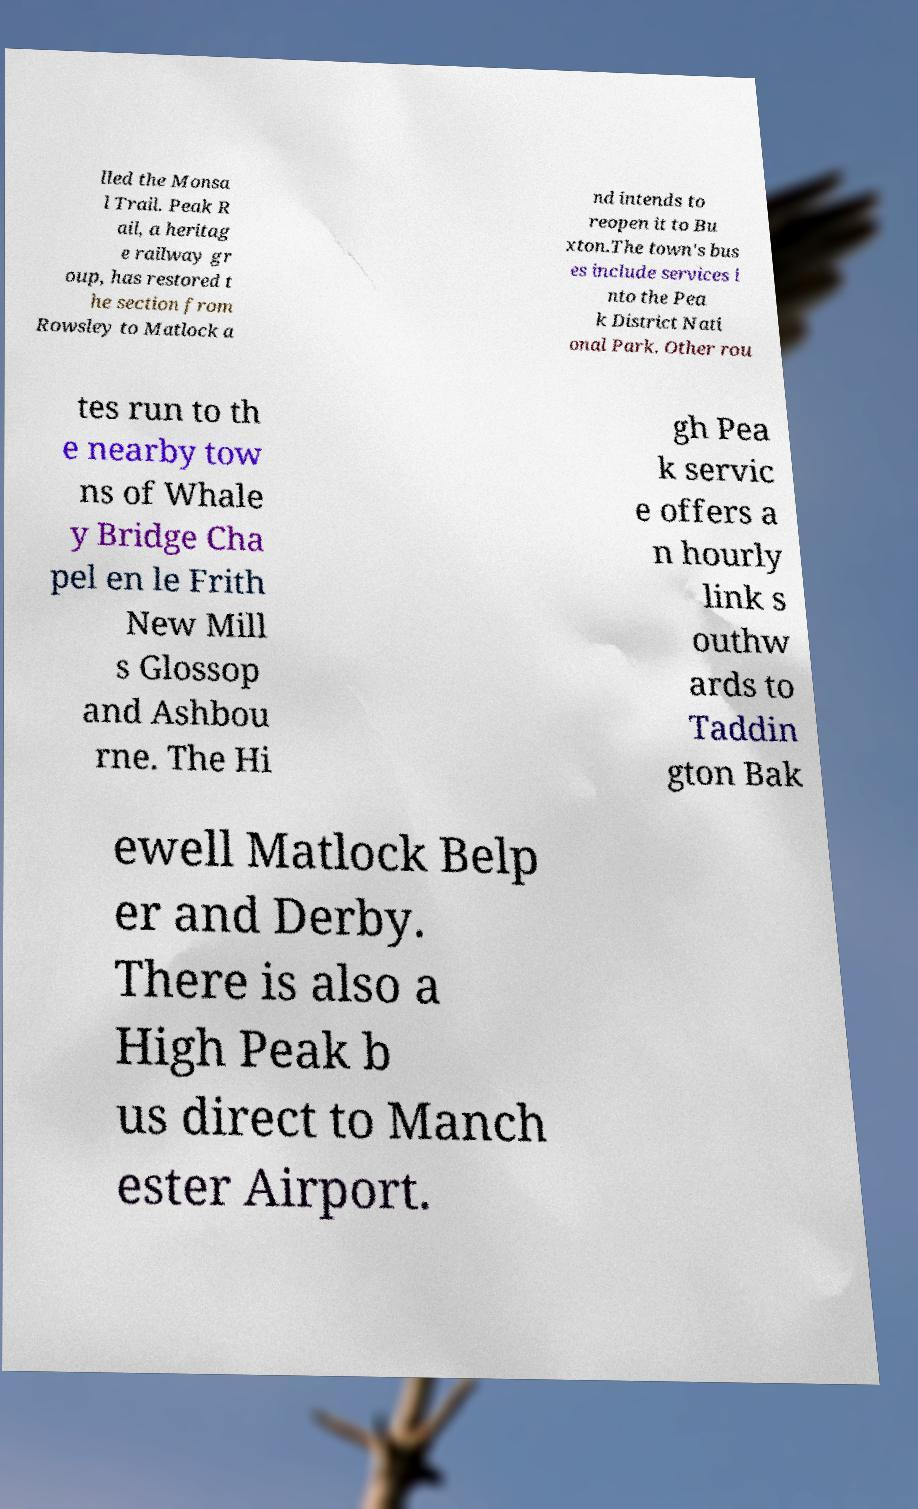There's text embedded in this image that I need extracted. Can you transcribe it verbatim? lled the Monsa l Trail. Peak R ail, a heritag e railway gr oup, has restored t he section from Rowsley to Matlock a nd intends to reopen it to Bu xton.The town's bus es include services i nto the Pea k District Nati onal Park. Other rou tes run to th e nearby tow ns of Whale y Bridge Cha pel en le Frith New Mill s Glossop and Ashbou rne. The Hi gh Pea k servic e offers a n hourly link s outhw ards to Taddin gton Bak ewell Matlock Belp er and Derby. There is also a High Peak b us direct to Manch ester Airport. 